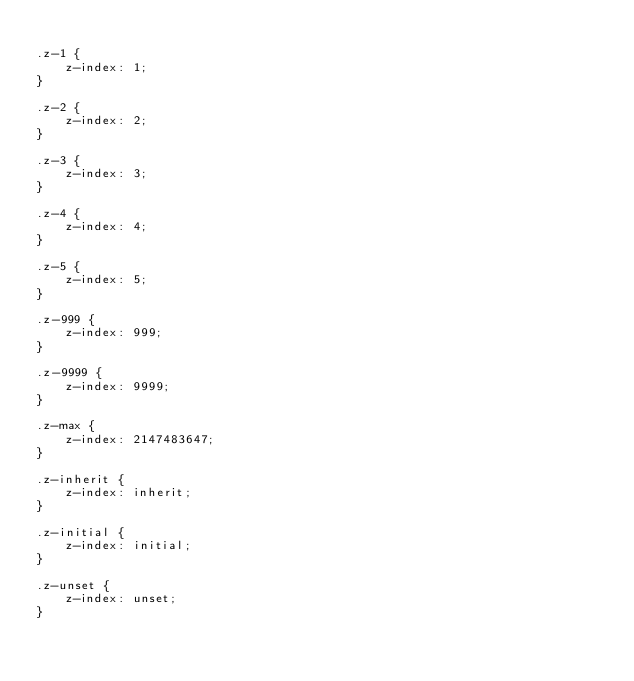<code> <loc_0><loc_0><loc_500><loc_500><_CSS_>
.z-1 {
    z-index: 1;
}

.z-2 {
    z-index: 2;
}

.z-3 {
    z-index: 3;
}

.z-4 {
    z-index: 4;
}

.z-5 {
    z-index: 5;
}

.z-999 {
    z-index: 999;
}

.z-9999 {
    z-index: 9999;
}

.z-max {
    z-index: 2147483647;
}

.z-inherit {
    z-index: inherit;
}

.z-initial {
    z-index: initial;
}

.z-unset {
    z-index: unset;
}
</code> 